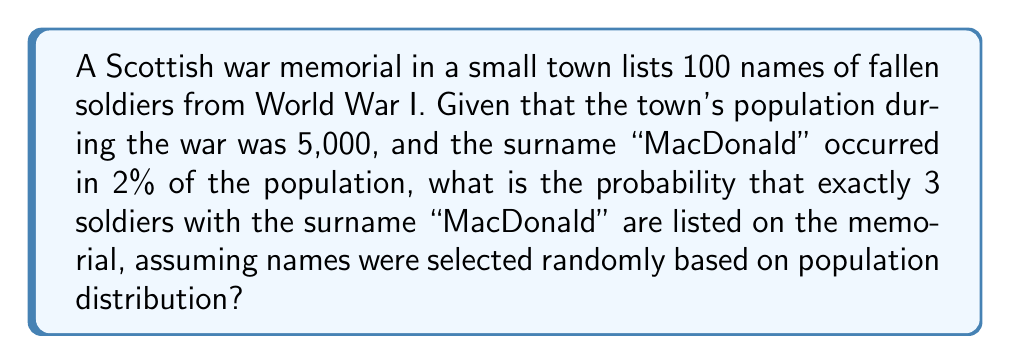What is the answer to this math problem? To solve this problem, we can use the binomial probability distribution:

1) Let $p$ be the probability of a single name being "MacDonald": $p = 0.02$

2) Let $n$ be the number of names on the memorial: $n = 100$

3) We want the probability of exactly $k = 3$ "MacDonald" names

4) The binomial probability formula is:

   $$P(X = k) = \binom{n}{k} p^k (1-p)^{n-k}$$

5) Substituting our values:

   $$P(X = 3) = \binom{100}{3} (0.02)^3 (0.98)^{97}$$

6) Calculate the binomial coefficient:
   
   $$\binom{100}{3} = \frac{100!}{3!(100-3)!} = \frac{100!}{3!97!} = 161,700$$

7) Now substitute this value:

   $$P(X = 3) = 161,700 \cdot (0.02)^3 \cdot (0.98)^{97}$$

8) Calculate:
   
   $$P(X = 3) = 161,700 \cdot 0.000008 \cdot 0.1441 \approx 0.1863$$

Therefore, the probability is approximately 0.1863 or 18.63%.
Answer: 0.1863 